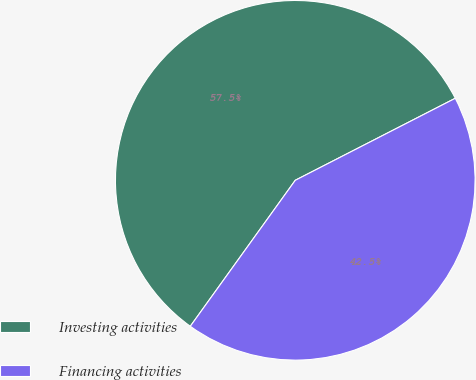<chart> <loc_0><loc_0><loc_500><loc_500><pie_chart><fcel>Investing activities<fcel>Financing activities<nl><fcel>57.54%<fcel>42.46%<nl></chart> 